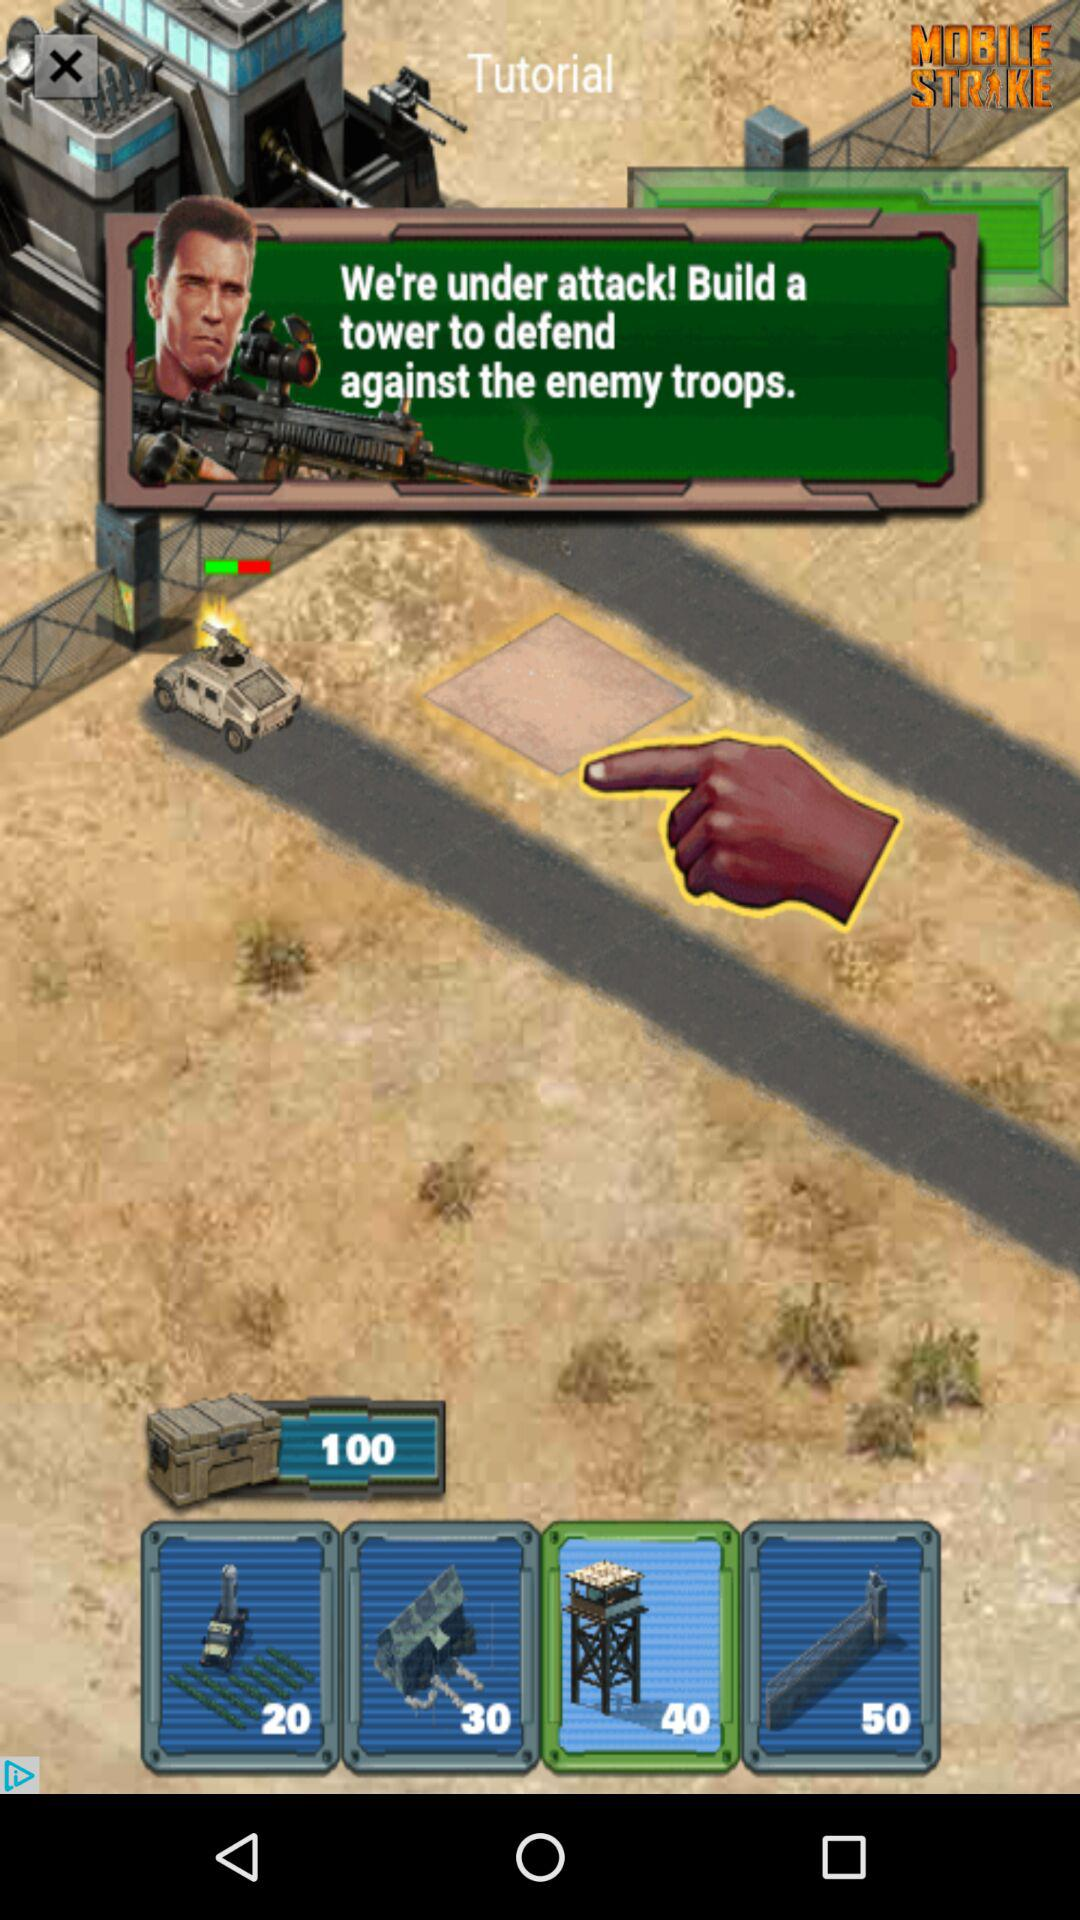How many more dollars does the 50 cost than the 30?
Answer the question using a single word or phrase. 20 